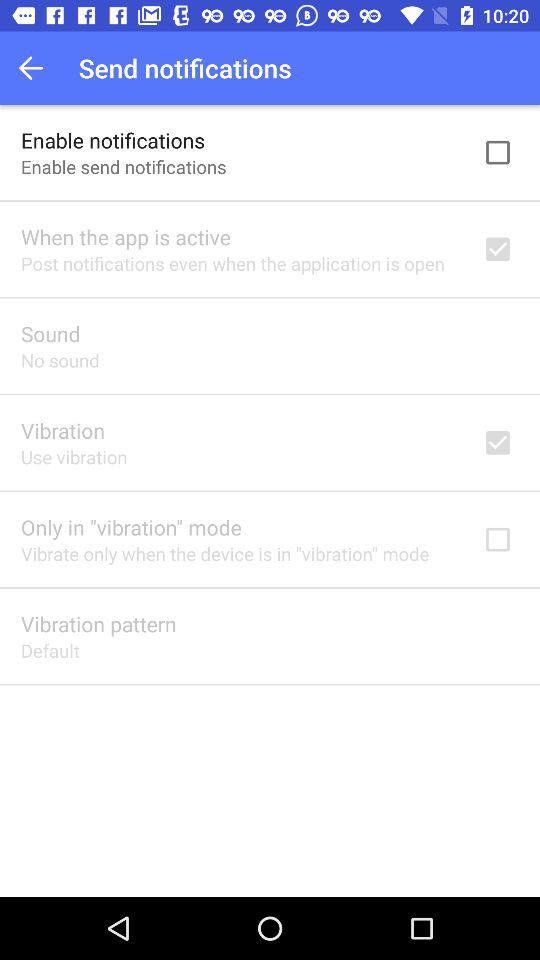Is "Enable notifications" checked or unchecked? "Enable notifications" is unchecked. 